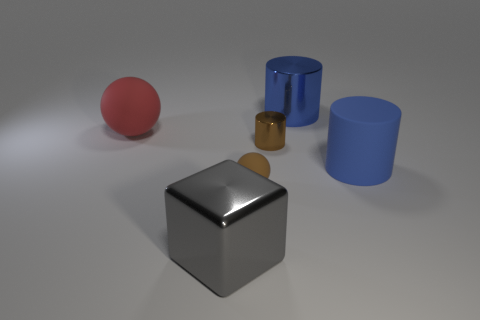There is a matte thing that is both on the left side of the large blue shiny object and to the right of the red object; what color is it?
Offer a very short reply. Brown. Is there a red cylinder?
Keep it short and to the point. No. Is the number of large shiny cylinders that are on the left side of the small matte object the same as the number of tiny red matte spheres?
Your response must be concise. Yes. How many other things are there of the same shape as the small metal thing?
Your answer should be compact. 2. What is the shape of the large red matte object?
Your response must be concise. Sphere. Do the cube and the tiny cylinder have the same material?
Ensure brevity in your answer.  Yes. Is the number of small brown rubber spheres behind the tiny metal cylinder the same as the number of small brown spheres to the right of the big blue metallic cylinder?
Your answer should be very brief. Yes. Is there a brown metal cylinder that is right of the sphere right of the big metallic object that is in front of the small brown matte thing?
Offer a terse response. Yes. Is the size of the shiny cube the same as the red thing?
Ensure brevity in your answer.  Yes. What color is the large cylinder in front of the cylinder that is to the left of the large shiny thing behind the brown rubber object?
Your answer should be compact. Blue. 